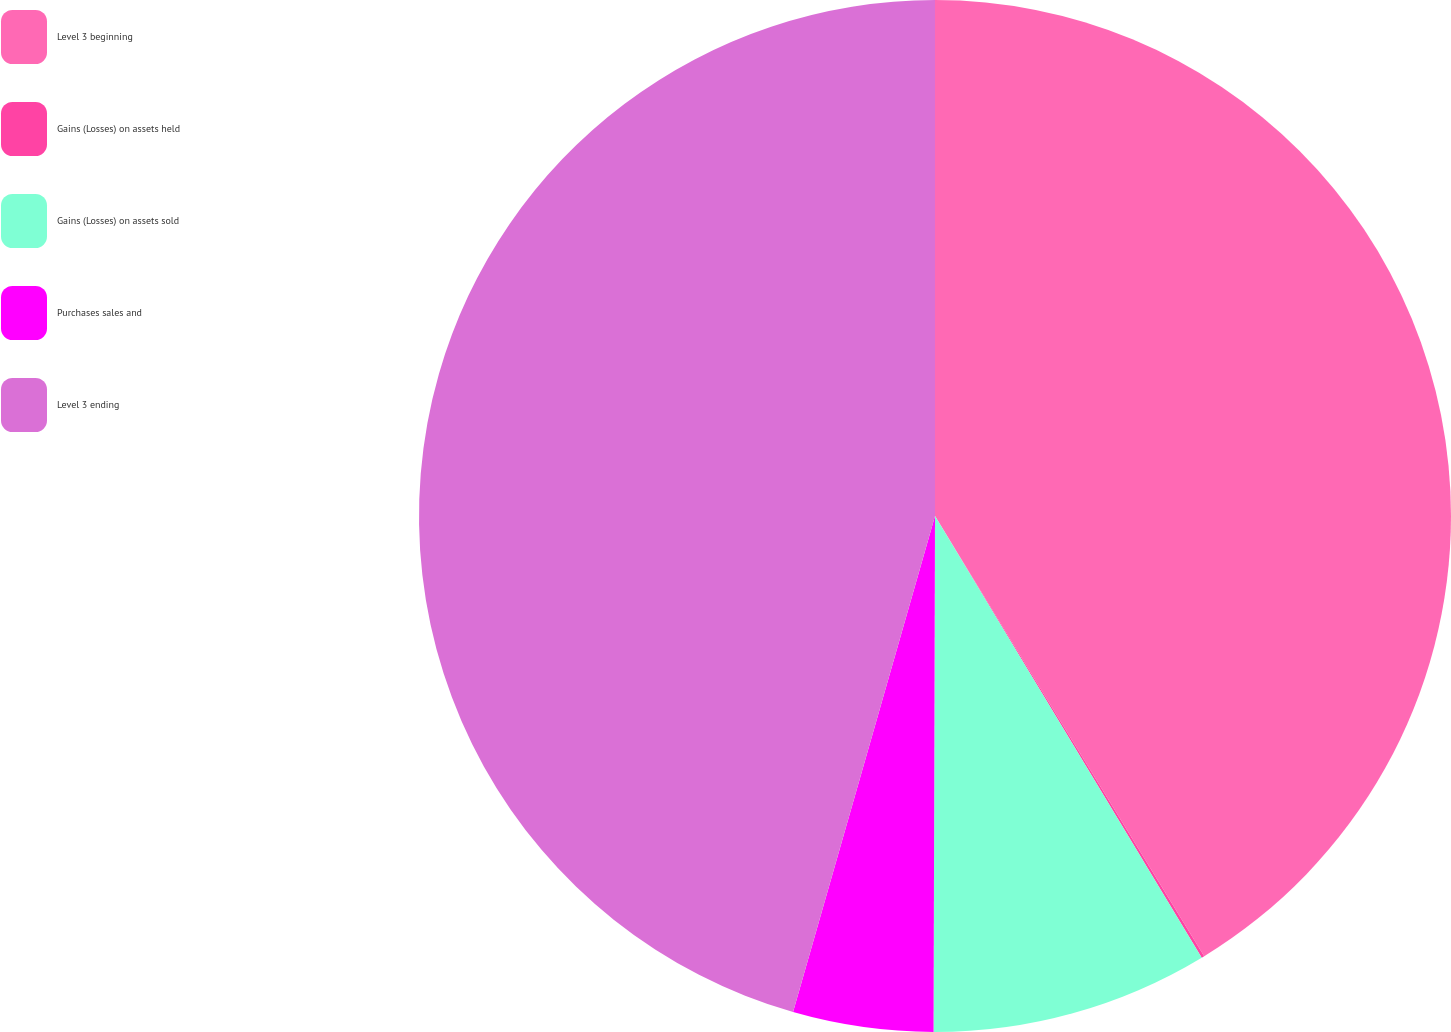Convert chart. <chart><loc_0><loc_0><loc_500><loc_500><pie_chart><fcel>Level 3 beginning<fcel>Gains (Losses) on assets held<fcel>Gains (Losses) on assets sold<fcel>Purchases sales and<fcel>Level 3 ending<nl><fcel>41.26%<fcel>0.09%<fcel>8.69%<fcel>4.39%<fcel>45.56%<nl></chart> 